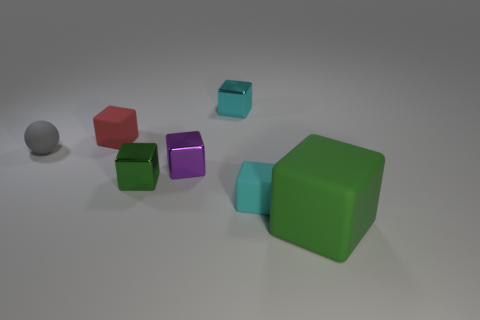Is there any other thing that is the same shape as the small gray thing?
Ensure brevity in your answer.  No. How many small objects have the same color as the ball?
Offer a very short reply. 0. There is a green metallic block; are there any large green matte blocks to the left of it?
Ensure brevity in your answer.  No. Is the number of small cyan metal blocks that are in front of the cyan metal block the same as the number of green metal cubes on the right side of the green metallic object?
Ensure brevity in your answer.  Yes. There is a rubber cube on the left side of the cyan shiny object; does it have the same size as the green thing that is on the right side of the tiny purple metallic object?
Your response must be concise. No. There is a small rubber object right of the small cyan block that is behind the green cube that is on the left side of the large object; what is its shape?
Your response must be concise. Cube. There is a green matte object that is the same shape as the small cyan rubber object; what size is it?
Offer a very short reply. Large. What is the color of the rubber cube that is both in front of the red matte cube and behind the large rubber thing?
Your answer should be very brief. Cyan. Is the material of the small green block the same as the object in front of the small cyan rubber thing?
Your answer should be compact. No. Are there fewer cyan rubber things left of the small gray sphere than small cyan rubber cubes?
Ensure brevity in your answer.  Yes. 